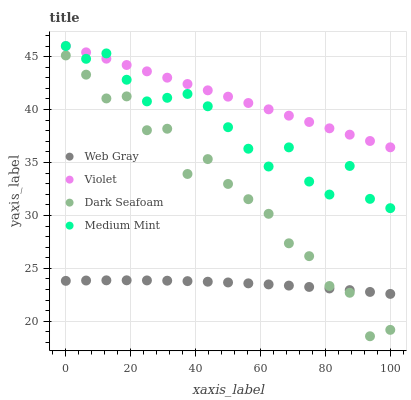Does Web Gray have the minimum area under the curve?
Answer yes or no. Yes. Does Violet have the maximum area under the curve?
Answer yes or no. Yes. Does Dark Seafoam have the minimum area under the curve?
Answer yes or no. No. Does Dark Seafoam have the maximum area under the curve?
Answer yes or no. No. Is Violet the smoothest?
Answer yes or no. Yes. Is Dark Seafoam the roughest?
Answer yes or no. Yes. Is Web Gray the smoothest?
Answer yes or no. No. Is Web Gray the roughest?
Answer yes or no. No. Does Dark Seafoam have the lowest value?
Answer yes or no. Yes. Does Web Gray have the lowest value?
Answer yes or no. No. Does Violet have the highest value?
Answer yes or no. Yes. Does Dark Seafoam have the highest value?
Answer yes or no. No. Is Dark Seafoam less than Medium Mint?
Answer yes or no. Yes. Is Medium Mint greater than Dark Seafoam?
Answer yes or no. Yes. Does Violet intersect Medium Mint?
Answer yes or no. Yes. Is Violet less than Medium Mint?
Answer yes or no. No. Is Violet greater than Medium Mint?
Answer yes or no. No. Does Dark Seafoam intersect Medium Mint?
Answer yes or no. No. 